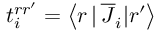<formula> <loc_0><loc_0><loc_500><loc_500>t _ { i } ^ { r r ^ { \prime } } = \left \langle r \, | \, \overline { J } _ { i } | r ^ { \prime } \right \rangle</formula> 